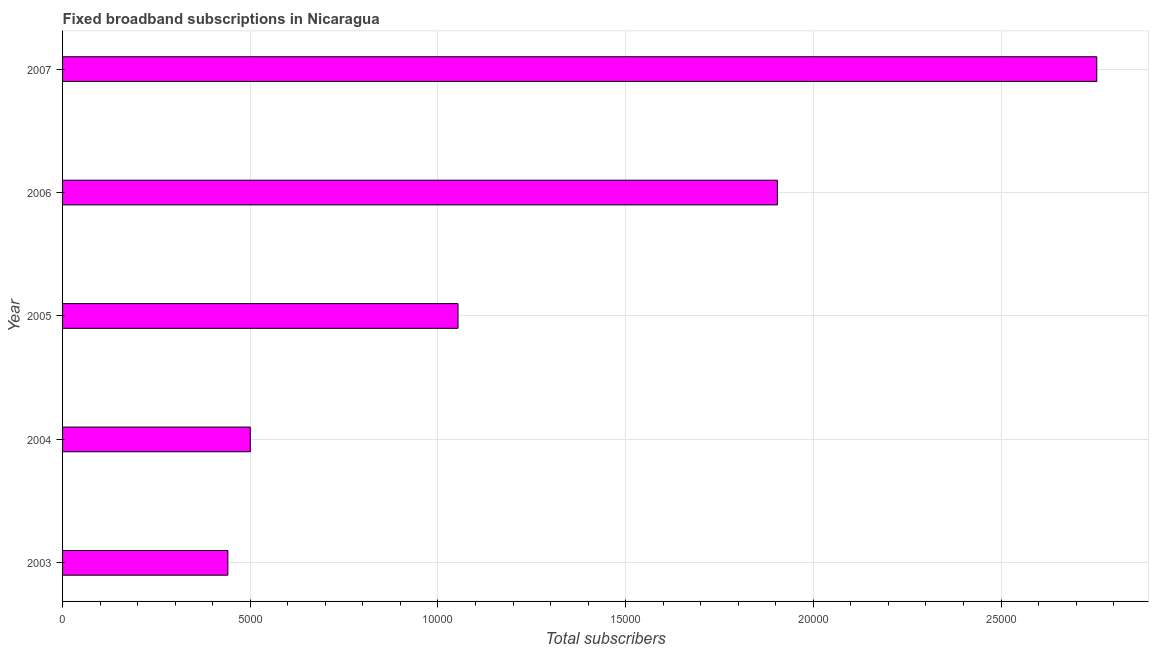Does the graph contain grids?
Your answer should be very brief. Yes. What is the title of the graph?
Give a very brief answer. Fixed broadband subscriptions in Nicaragua. What is the label or title of the X-axis?
Offer a terse response. Total subscribers. What is the total number of fixed broadband subscriptions in 2005?
Your answer should be compact. 1.05e+04. Across all years, what is the maximum total number of fixed broadband subscriptions?
Offer a terse response. 2.76e+04. Across all years, what is the minimum total number of fixed broadband subscriptions?
Offer a very short reply. 4403. What is the sum of the total number of fixed broadband subscriptions?
Provide a succinct answer. 6.65e+04. What is the difference between the total number of fixed broadband subscriptions in 2003 and 2006?
Offer a very short reply. -1.46e+04. What is the average total number of fixed broadband subscriptions per year?
Keep it short and to the point. 1.33e+04. What is the median total number of fixed broadband subscriptions?
Provide a succinct answer. 1.05e+04. In how many years, is the total number of fixed broadband subscriptions greater than 13000 ?
Give a very brief answer. 2. What is the ratio of the total number of fixed broadband subscriptions in 2003 to that in 2006?
Offer a terse response. 0.23. What is the difference between the highest and the second highest total number of fixed broadband subscriptions?
Your response must be concise. 8508. Is the sum of the total number of fixed broadband subscriptions in 2003 and 2007 greater than the maximum total number of fixed broadband subscriptions across all years?
Your answer should be very brief. Yes. What is the difference between the highest and the lowest total number of fixed broadband subscriptions?
Keep it short and to the point. 2.31e+04. In how many years, is the total number of fixed broadband subscriptions greater than the average total number of fixed broadband subscriptions taken over all years?
Offer a very short reply. 2. How many bars are there?
Provide a succinct answer. 5. What is the difference between two consecutive major ticks on the X-axis?
Your answer should be very brief. 5000. What is the Total subscribers in 2003?
Your answer should be compact. 4403. What is the Total subscribers of 2004?
Offer a very short reply. 5001. What is the Total subscribers of 2005?
Your response must be concise. 1.05e+04. What is the Total subscribers in 2006?
Your answer should be very brief. 1.90e+04. What is the Total subscribers of 2007?
Your answer should be very brief. 2.76e+04. What is the difference between the Total subscribers in 2003 and 2004?
Make the answer very short. -598. What is the difference between the Total subscribers in 2003 and 2005?
Your answer should be compact. -6131. What is the difference between the Total subscribers in 2003 and 2006?
Provide a short and direct response. -1.46e+04. What is the difference between the Total subscribers in 2003 and 2007?
Provide a short and direct response. -2.31e+04. What is the difference between the Total subscribers in 2004 and 2005?
Give a very brief answer. -5533. What is the difference between the Total subscribers in 2004 and 2006?
Provide a succinct answer. -1.40e+04. What is the difference between the Total subscribers in 2004 and 2007?
Your response must be concise. -2.25e+04. What is the difference between the Total subscribers in 2005 and 2006?
Offer a very short reply. -8508. What is the difference between the Total subscribers in 2005 and 2007?
Offer a terse response. -1.70e+04. What is the difference between the Total subscribers in 2006 and 2007?
Your answer should be compact. -8508. What is the ratio of the Total subscribers in 2003 to that in 2004?
Your answer should be compact. 0.88. What is the ratio of the Total subscribers in 2003 to that in 2005?
Keep it short and to the point. 0.42. What is the ratio of the Total subscribers in 2003 to that in 2006?
Keep it short and to the point. 0.23. What is the ratio of the Total subscribers in 2003 to that in 2007?
Your answer should be very brief. 0.16. What is the ratio of the Total subscribers in 2004 to that in 2005?
Give a very brief answer. 0.47. What is the ratio of the Total subscribers in 2004 to that in 2006?
Keep it short and to the point. 0.26. What is the ratio of the Total subscribers in 2004 to that in 2007?
Keep it short and to the point. 0.18. What is the ratio of the Total subscribers in 2005 to that in 2006?
Keep it short and to the point. 0.55. What is the ratio of the Total subscribers in 2005 to that in 2007?
Ensure brevity in your answer.  0.38. What is the ratio of the Total subscribers in 2006 to that in 2007?
Your response must be concise. 0.69. 